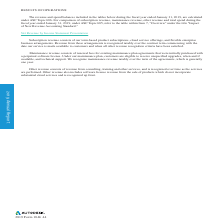According to Autodesk's financial document, What is the impact of foreign exchange rate changes on net revenue? Based on the financial document, the answer is Positive. Also, Which foreign exchange rate is likely to have the most impact on the company's operations? Based on the financial document, the answer is U.S. dollar. Also, How does the company make use of foreign currency contracts? Based on the financial document, the answer is reduce the exchange rate effect on a portion of the net revenue of certain anticipated transactions. Also, How many countries make up most of the company's revenue? Counting the relevant items in the document: United States, Germany, Japan, the United Kingdom, Canada, I find 5 instances. The key data points involved are: Canada, Germany, Japan. Also, can you calculate: How much did the foreign exchange rate changes impact percent change in revenue? Based on the calculation: 25%-24% , the result is 1 (percentage). The key data points involved are: 24, 25. Also, can you calculate: How much did the foreign exchange rate changes impact percent change in total spend? I cannot find a specific answer to this question in the financial document. 